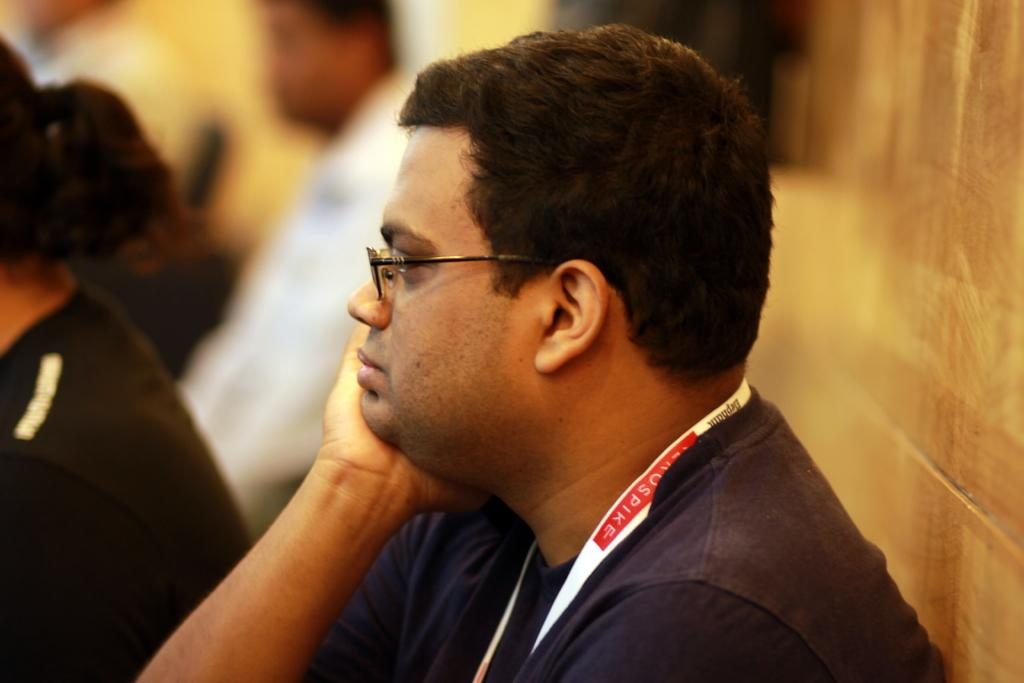What is the main subject of the image? There is a person sitting in the center of the image. Can you describe the person's appearance? The person is wearing spectacles. What can be seen in the background of the image? There are persons visible in the background of the image, and there is a wall. What type of jar is being used by the beetle in the image? There is no beetle or jar present in the image. What is the person holding in their hand in the image? The provided facts do not mention any object being held by the person in the image. 